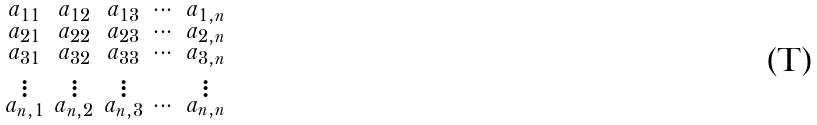Convert formula to latex. <formula><loc_0><loc_0><loc_500><loc_500>\begin{smallmatrix} a _ { 1 1 } & a _ { 1 2 } & a _ { 1 3 } & \cdots & a _ { 1 , n } \\ a _ { 2 1 } & a _ { 2 2 } & a _ { 2 3 } & \cdots & a _ { 2 , n } \\ a _ { 3 1 } & a _ { 3 2 } & a _ { 3 3 } & \cdots & a _ { 3 , n } \\ \vdots & \vdots & \vdots & & \vdots \\ a _ { n , 1 } & a _ { n , 2 } & a _ { n , 3 } & \cdots & a _ { n , n } \end{smallmatrix}</formula> 